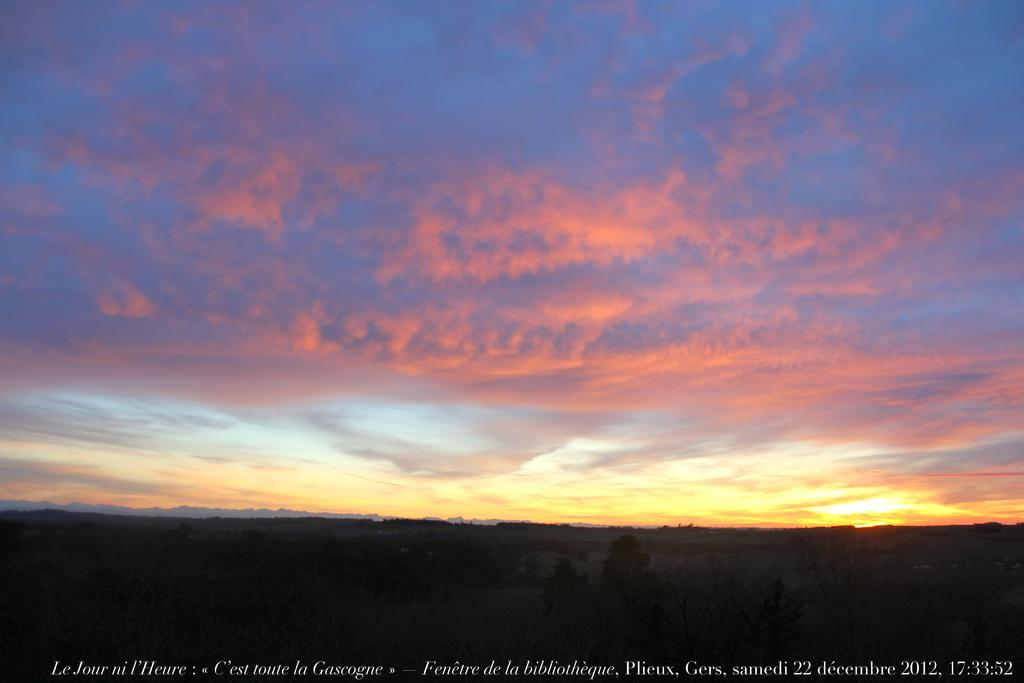What can be seen at the top of the image? The sky is visible in the image. What is present in the sky? There are clouds in the sky. What type of vegetation is at the bottom of the image? Trees are present at the bottom of the image. What else can be seen in the image besides the sky and trees? There is text visible in the image. Did the approval rating for the new policy increase during the earthquake depicted in the image? There is no earthquake or approval rating mentioned in the image, so it is not possible to answer that question. 